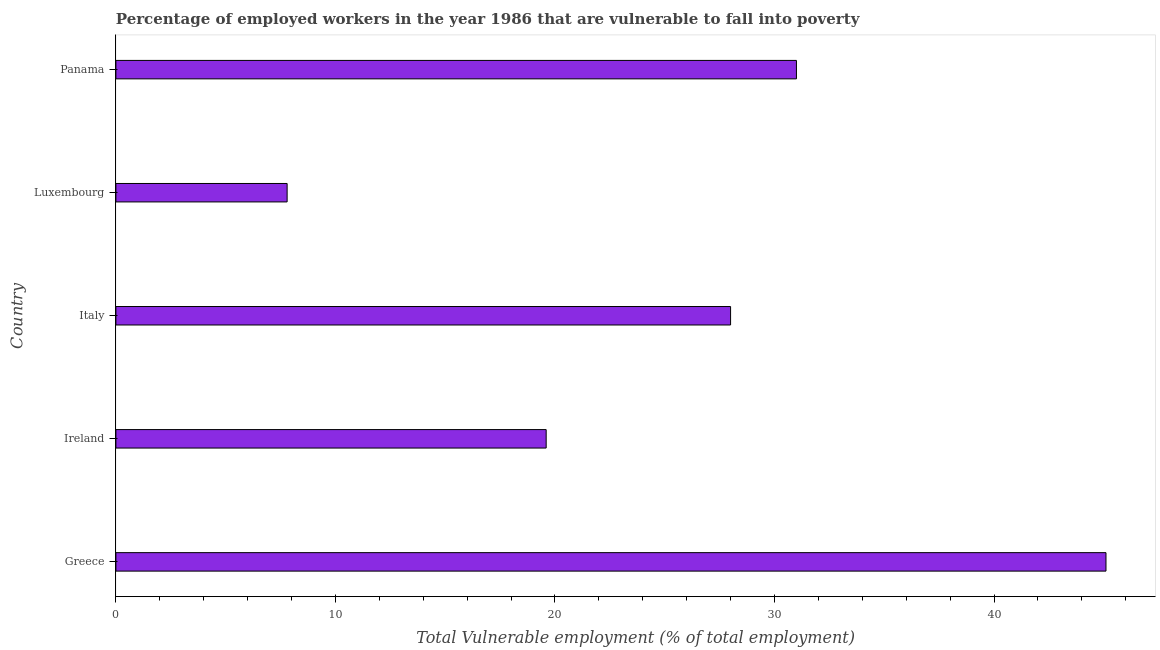Does the graph contain any zero values?
Provide a succinct answer. No. Does the graph contain grids?
Your answer should be very brief. No. What is the title of the graph?
Your answer should be compact. Percentage of employed workers in the year 1986 that are vulnerable to fall into poverty. What is the label or title of the X-axis?
Provide a short and direct response. Total Vulnerable employment (% of total employment). Across all countries, what is the maximum total vulnerable employment?
Offer a very short reply. 45.1. Across all countries, what is the minimum total vulnerable employment?
Offer a terse response. 7.8. In which country was the total vulnerable employment minimum?
Offer a very short reply. Luxembourg. What is the sum of the total vulnerable employment?
Keep it short and to the point. 131.5. What is the average total vulnerable employment per country?
Offer a very short reply. 26.3. What is the median total vulnerable employment?
Offer a terse response. 28. In how many countries, is the total vulnerable employment greater than 30 %?
Your answer should be very brief. 2. What is the ratio of the total vulnerable employment in Italy to that in Panama?
Provide a short and direct response. 0.9. Is the difference between the total vulnerable employment in Italy and Luxembourg greater than the difference between any two countries?
Your answer should be very brief. No. What is the difference between the highest and the second highest total vulnerable employment?
Provide a succinct answer. 14.1. Is the sum of the total vulnerable employment in Greece and Luxembourg greater than the maximum total vulnerable employment across all countries?
Your answer should be very brief. Yes. What is the difference between the highest and the lowest total vulnerable employment?
Your answer should be very brief. 37.3. In how many countries, is the total vulnerable employment greater than the average total vulnerable employment taken over all countries?
Keep it short and to the point. 3. How many countries are there in the graph?
Your response must be concise. 5. What is the difference between two consecutive major ticks on the X-axis?
Your answer should be very brief. 10. What is the Total Vulnerable employment (% of total employment) of Greece?
Provide a succinct answer. 45.1. What is the Total Vulnerable employment (% of total employment) of Ireland?
Your answer should be compact. 19.6. What is the Total Vulnerable employment (% of total employment) in Luxembourg?
Give a very brief answer. 7.8. What is the Total Vulnerable employment (% of total employment) of Panama?
Offer a very short reply. 31. What is the difference between the Total Vulnerable employment (% of total employment) in Greece and Ireland?
Keep it short and to the point. 25.5. What is the difference between the Total Vulnerable employment (% of total employment) in Greece and Italy?
Ensure brevity in your answer.  17.1. What is the difference between the Total Vulnerable employment (% of total employment) in Greece and Luxembourg?
Provide a short and direct response. 37.3. What is the difference between the Total Vulnerable employment (% of total employment) in Ireland and Luxembourg?
Your answer should be very brief. 11.8. What is the difference between the Total Vulnerable employment (% of total employment) in Ireland and Panama?
Make the answer very short. -11.4. What is the difference between the Total Vulnerable employment (% of total employment) in Italy and Luxembourg?
Your answer should be very brief. 20.2. What is the difference between the Total Vulnerable employment (% of total employment) in Italy and Panama?
Provide a short and direct response. -3. What is the difference between the Total Vulnerable employment (% of total employment) in Luxembourg and Panama?
Provide a short and direct response. -23.2. What is the ratio of the Total Vulnerable employment (% of total employment) in Greece to that in Ireland?
Offer a very short reply. 2.3. What is the ratio of the Total Vulnerable employment (% of total employment) in Greece to that in Italy?
Your answer should be compact. 1.61. What is the ratio of the Total Vulnerable employment (% of total employment) in Greece to that in Luxembourg?
Offer a very short reply. 5.78. What is the ratio of the Total Vulnerable employment (% of total employment) in Greece to that in Panama?
Provide a succinct answer. 1.46. What is the ratio of the Total Vulnerable employment (% of total employment) in Ireland to that in Luxembourg?
Provide a short and direct response. 2.51. What is the ratio of the Total Vulnerable employment (% of total employment) in Ireland to that in Panama?
Give a very brief answer. 0.63. What is the ratio of the Total Vulnerable employment (% of total employment) in Italy to that in Luxembourg?
Your response must be concise. 3.59. What is the ratio of the Total Vulnerable employment (% of total employment) in Italy to that in Panama?
Your answer should be very brief. 0.9. What is the ratio of the Total Vulnerable employment (% of total employment) in Luxembourg to that in Panama?
Offer a terse response. 0.25. 